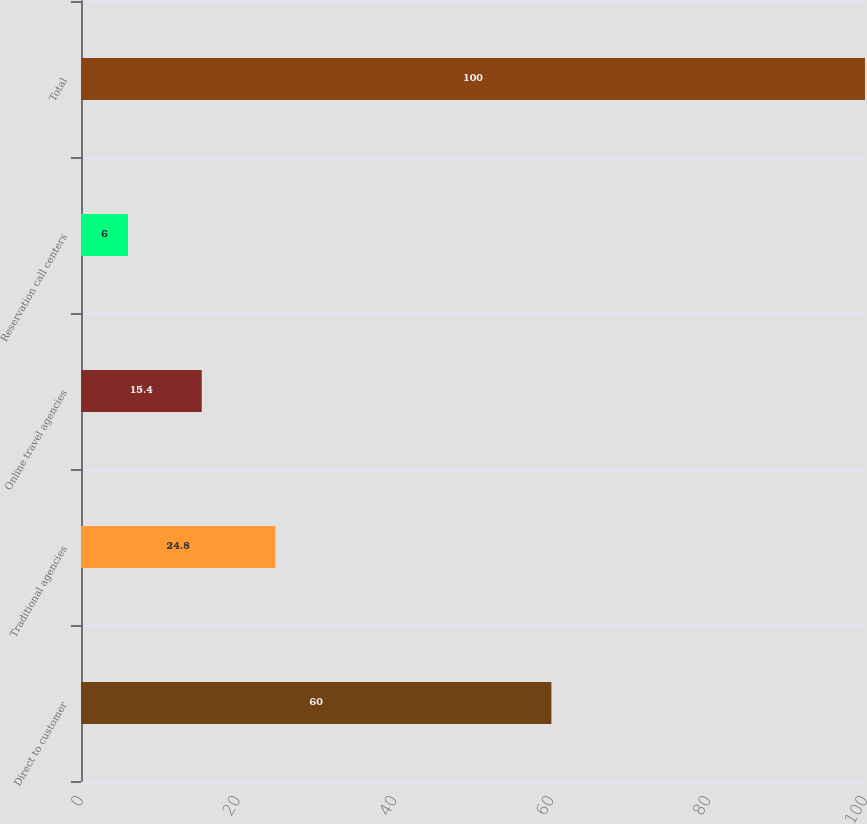Convert chart. <chart><loc_0><loc_0><loc_500><loc_500><bar_chart><fcel>Direct to customer<fcel>Traditional agencies<fcel>Online travel agencies<fcel>Reservation call centers<fcel>Total<nl><fcel>60<fcel>24.8<fcel>15.4<fcel>6<fcel>100<nl></chart> 